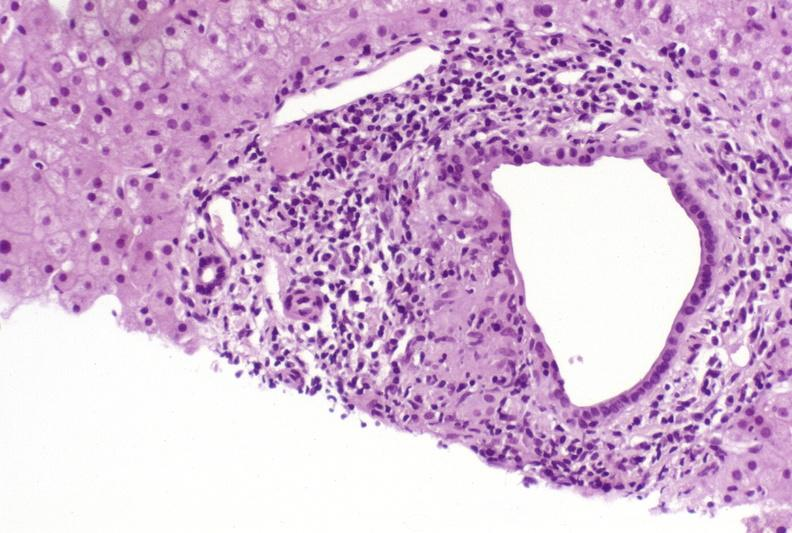s acute peritonitis present?
Answer the question using a single word or phrase. No 